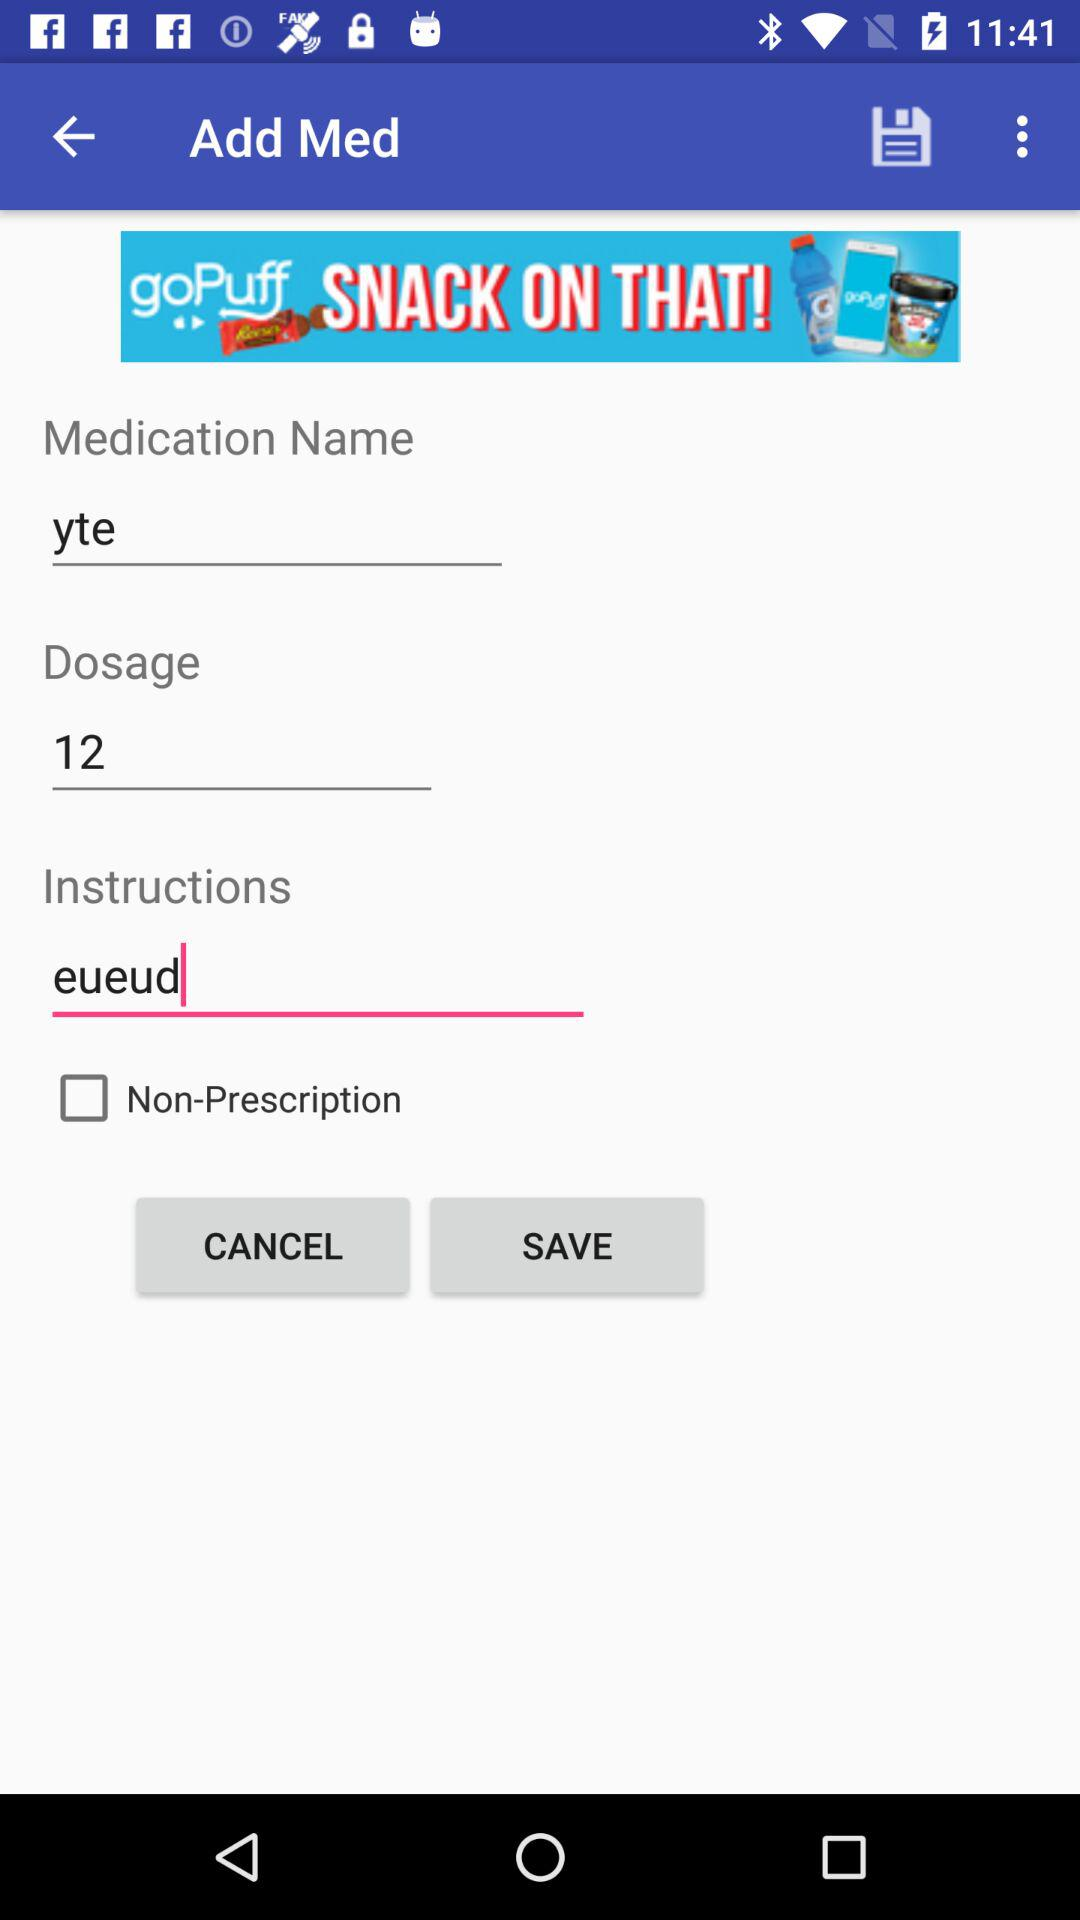What is entered in "Instructions"? In "Instructions", "eueud" is entered. 